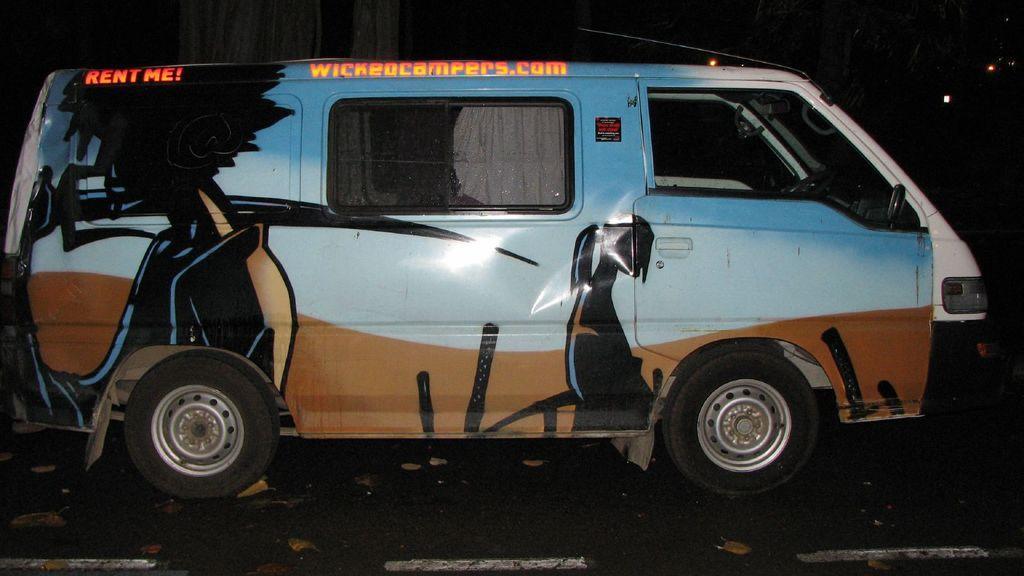Can you describe this image briefly? In this picture we can see a vehicle on the road and in the background it is dark. 